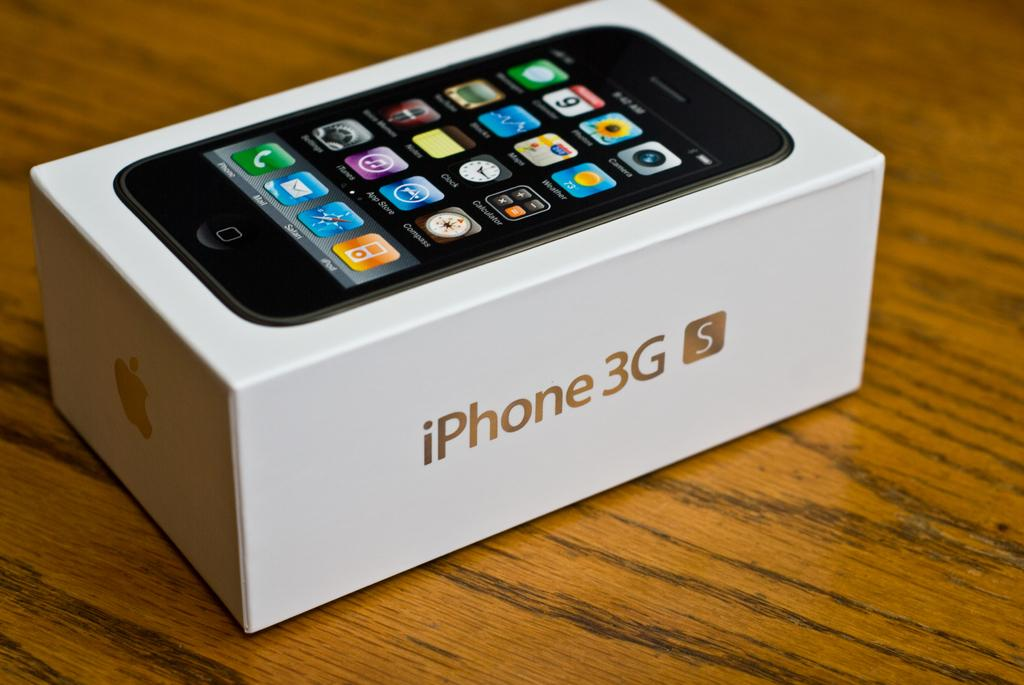<image>
Write a terse but informative summary of the picture. An iPhone 3G S box sits on a shiny faux wooden surface. 